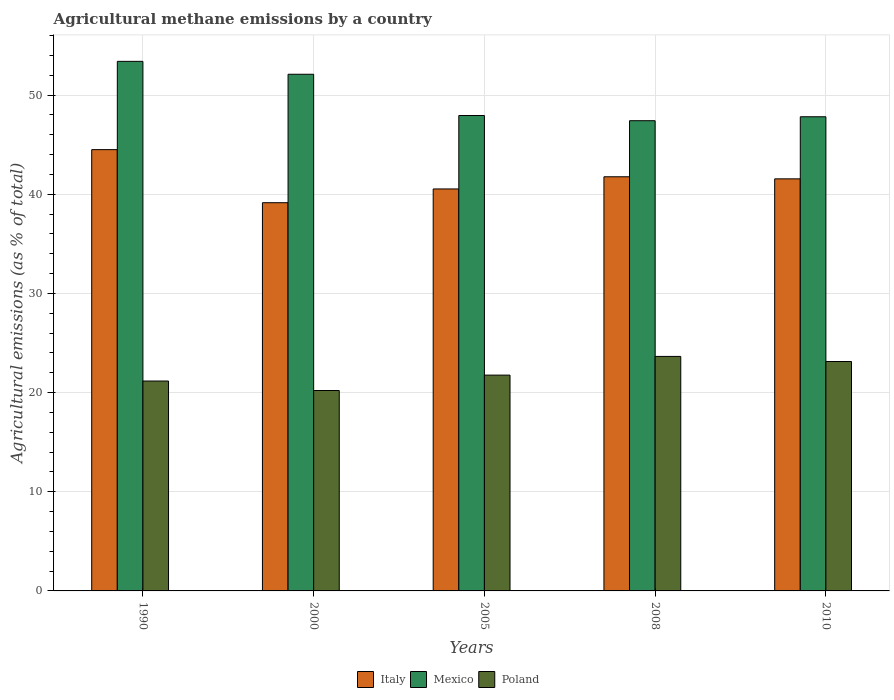How many groups of bars are there?
Your response must be concise. 5. How many bars are there on the 4th tick from the left?
Your answer should be very brief. 3. In how many cases, is the number of bars for a given year not equal to the number of legend labels?
Offer a terse response. 0. What is the amount of agricultural methane emitted in Mexico in 1990?
Provide a short and direct response. 53.39. Across all years, what is the maximum amount of agricultural methane emitted in Poland?
Ensure brevity in your answer.  23.64. Across all years, what is the minimum amount of agricultural methane emitted in Mexico?
Make the answer very short. 47.41. In which year was the amount of agricultural methane emitted in Poland maximum?
Offer a very short reply. 2008. In which year was the amount of agricultural methane emitted in Italy minimum?
Your answer should be compact. 2000. What is the total amount of agricultural methane emitted in Italy in the graph?
Offer a very short reply. 207.46. What is the difference between the amount of agricultural methane emitted in Italy in 2005 and that in 2010?
Keep it short and to the point. -1.02. What is the difference between the amount of agricultural methane emitted in Italy in 2000 and the amount of agricultural methane emitted in Poland in 2008?
Offer a very short reply. 15.5. What is the average amount of agricultural methane emitted in Poland per year?
Keep it short and to the point. 21.98. In the year 2008, what is the difference between the amount of agricultural methane emitted in Mexico and amount of agricultural methane emitted in Poland?
Your answer should be very brief. 23.77. What is the ratio of the amount of agricultural methane emitted in Italy in 2005 to that in 2010?
Your answer should be very brief. 0.98. Is the amount of agricultural methane emitted in Poland in 2005 less than that in 2010?
Provide a succinct answer. Yes. Is the difference between the amount of agricultural methane emitted in Mexico in 2000 and 2008 greater than the difference between the amount of agricultural methane emitted in Poland in 2000 and 2008?
Provide a short and direct response. Yes. What is the difference between the highest and the second highest amount of agricultural methane emitted in Italy?
Give a very brief answer. 2.74. What is the difference between the highest and the lowest amount of agricultural methane emitted in Mexico?
Keep it short and to the point. 5.98. What does the 3rd bar from the left in 2010 represents?
Provide a short and direct response. Poland. What does the 1st bar from the right in 2000 represents?
Offer a very short reply. Poland. Is it the case that in every year, the sum of the amount of agricultural methane emitted in Poland and amount of agricultural methane emitted in Italy is greater than the amount of agricultural methane emitted in Mexico?
Provide a succinct answer. Yes. How many bars are there?
Your answer should be very brief. 15. What is the difference between two consecutive major ticks on the Y-axis?
Your response must be concise. 10. Are the values on the major ticks of Y-axis written in scientific E-notation?
Make the answer very short. No. Where does the legend appear in the graph?
Your answer should be compact. Bottom center. How many legend labels are there?
Ensure brevity in your answer.  3. How are the legend labels stacked?
Offer a terse response. Horizontal. What is the title of the graph?
Provide a short and direct response. Agricultural methane emissions by a country. Does "Least developed countries" appear as one of the legend labels in the graph?
Give a very brief answer. No. What is the label or title of the Y-axis?
Offer a very short reply. Agricultural emissions (as % of total). What is the Agricultural emissions (as % of total) of Italy in 1990?
Provide a short and direct response. 44.49. What is the Agricultural emissions (as % of total) in Mexico in 1990?
Your answer should be compact. 53.39. What is the Agricultural emissions (as % of total) of Poland in 1990?
Provide a short and direct response. 21.16. What is the Agricultural emissions (as % of total) in Italy in 2000?
Your answer should be very brief. 39.14. What is the Agricultural emissions (as % of total) of Mexico in 2000?
Give a very brief answer. 52.09. What is the Agricultural emissions (as % of total) of Poland in 2000?
Your answer should be compact. 20.21. What is the Agricultural emissions (as % of total) in Italy in 2005?
Give a very brief answer. 40.53. What is the Agricultural emissions (as % of total) of Mexico in 2005?
Give a very brief answer. 47.93. What is the Agricultural emissions (as % of total) in Poland in 2005?
Ensure brevity in your answer.  21.76. What is the Agricultural emissions (as % of total) of Italy in 2008?
Provide a short and direct response. 41.76. What is the Agricultural emissions (as % of total) of Mexico in 2008?
Your answer should be compact. 47.41. What is the Agricultural emissions (as % of total) of Poland in 2008?
Make the answer very short. 23.64. What is the Agricultural emissions (as % of total) of Italy in 2010?
Provide a succinct answer. 41.55. What is the Agricultural emissions (as % of total) of Mexico in 2010?
Make the answer very short. 47.81. What is the Agricultural emissions (as % of total) in Poland in 2010?
Ensure brevity in your answer.  23.13. Across all years, what is the maximum Agricultural emissions (as % of total) in Italy?
Give a very brief answer. 44.49. Across all years, what is the maximum Agricultural emissions (as % of total) in Mexico?
Keep it short and to the point. 53.39. Across all years, what is the maximum Agricultural emissions (as % of total) of Poland?
Provide a short and direct response. 23.64. Across all years, what is the minimum Agricultural emissions (as % of total) of Italy?
Your answer should be very brief. 39.14. Across all years, what is the minimum Agricultural emissions (as % of total) in Mexico?
Your answer should be compact. 47.41. Across all years, what is the minimum Agricultural emissions (as % of total) of Poland?
Offer a very short reply. 20.21. What is the total Agricultural emissions (as % of total) of Italy in the graph?
Your response must be concise. 207.46. What is the total Agricultural emissions (as % of total) in Mexico in the graph?
Provide a succinct answer. 248.63. What is the total Agricultural emissions (as % of total) in Poland in the graph?
Ensure brevity in your answer.  109.9. What is the difference between the Agricultural emissions (as % of total) in Italy in 1990 and that in 2000?
Provide a succinct answer. 5.35. What is the difference between the Agricultural emissions (as % of total) in Mexico in 1990 and that in 2000?
Offer a terse response. 1.3. What is the difference between the Agricultural emissions (as % of total) in Poland in 1990 and that in 2000?
Make the answer very short. 0.96. What is the difference between the Agricultural emissions (as % of total) of Italy in 1990 and that in 2005?
Offer a terse response. 3.96. What is the difference between the Agricultural emissions (as % of total) in Mexico in 1990 and that in 2005?
Ensure brevity in your answer.  5.46. What is the difference between the Agricultural emissions (as % of total) in Poland in 1990 and that in 2005?
Provide a short and direct response. -0.6. What is the difference between the Agricultural emissions (as % of total) in Italy in 1990 and that in 2008?
Offer a very short reply. 2.74. What is the difference between the Agricultural emissions (as % of total) of Mexico in 1990 and that in 2008?
Provide a short and direct response. 5.98. What is the difference between the Agricultural emissions (as % of total) of Poland in 1990 and that in 2008?
Your response must be concise. -2.48. What is the difference between the Agricultural emissions (as % of total) of Italy in 1990 and that in 2010?
Your response must be concise. 2.95. What is the difference between the Agricultural emissions (as % of total) in Mexico in 1990 and that in 2010?
Provide a short and direct response. 5.59. What is the difference between the Agricultural emissions (as % of total) in Poland in 1990 and that in 2010?
Offer a very short reply. -1.97. What is the difference between the Agricultural emissions (as % of total) of Italy in 2000 and that in 2005?
Provide a succinct answer. -1.39. What is the difference between the Agricultural emissions (as % of total) of Mexico in 2000 and that in 2005?
Your response must be concise. 4.16. What is the difference between the Agricultural emissions (as % of total) of Poland in 2000 and that in 2005?
Give a very brief answer. -1.55. What is the difference between the Agricultural emissions (as % of total) in Italy in 2000 and that in 2008?
Offer a terse response. -2.62. What is the difference between the Agricultural emissions (as % of total) in Mexico in 2000 and that in 2008?
Give a very brief answer. 4.68. What is the difference between the Agricultural emissions (as % of total) of Poland in 2000 and that in 2008?
Provide a short and direct response. -3.44. What is the difference between the Agricultural emissions (as % of total) of Italy in 2000 and that in 2010?
Offer a terse response. -2.41. What is the difference between the Agricultural emissions (as % of total) of Mexico in 2000 and that in 2010?
Your response must be concise. 4.29. What is the difference between the Agricultural emissions (as % of total) in Poland in 2000 and that in 2010?
Provide a short and direct response. -2.92. What is the difference between the Agricultural emissions (as % of total) of Italy in 2005 and that in 2008?
Offer a terse response. -1.23. What is the difference between the Agricultural emissions (as % of total) of Mexico in 2005 and that in 2008?
Provide a succinct answer. 0.52. What is the difference between the Agricultural emissions (as % of total) in Poland in 2005 and that in 2008?
Your answer should be compact. -1.88. What is the difference between the Agricultural emissions (as % of total) of Italy in 2005 and that in 2010?
Give a very brief answer. -1.02. What is the difference between the Agricultural emissions (as % of total) of Mexico in 2005 and that in 2010?
Provide a short and direct response. 0.13. What is the difference between the Agricultural emissions (as % of total) of Poland in 2005 and that in 2010?
Keep it short and to the point. -1.37. What is the difference between the Agricultural emissions (as % of total) of Italy in 2008 and that in 2010?
Your answer should be compact. 0.21. What is the difference between the Agricultural emissions (as % of total) of Mexico in 2008 and that in 2010?
Offer a very short reply. -0.4. What is the difference between the Agricultural emissions (as % of total) in Poland in 2008 and that in 2010?
Make the answer very short. 0.51. What is the difference between the Agricultural emissions (as % of total) of Italy in 1990 and the Agricultural emissions (as % of total) of Mexico in 2000?
Keep it short and to the point. -7.6. What is the difference between the Agricultural emissions (as % of total) in Italy in 1990 and the Agricultural emissions (as % of total) in Poland in 2000?
Offer a very short reply. 24.29. What is the difference between the Agricultural emissions (as % of total) of Mexico in 1990 and the Agricultural emissions (as % of total) of Poland in 2000?
Your answer should be very brief. 33.19. What is the difference between the Agricultural emissions (as % of total) of Italy in 1990 and the Agricultural emissions (as % of total) of Mexico in 2005?
Ensure brevity in your answer.  -3.44. What is the difference between the Agricultural emissions (as % of total) in Italy in 1990 and the Agricultural emissions (as % of total) in Poland in 2005?
Provide a succinct answer. 22.73. What is the difference between the Agricultural emissions (as % of total) of Mexico in 1990 and the Agricultural emissions (as % of total) of Poland in 2005?
Keep it short and to the point. 31.63. What is the difference between the Agricultural emissions (as % of total) in Italy in 1990 and the Agricultural emissions (as % of total) in Mexico in 2008?
Provide a short and direct response. -2.92. What is the difference between the Agricultural emissions (as % of total) in Italy in 1990 and the Agricultural emissions (as % of total) in Poland in 2008?
Ensure brevity in your answer.  20.85. What is the difference between the Agricultural emissions (as % of total) of Mexico in 1990 and the Agricultural emissions (as % of total) of Poland in 2008?
Your answer should be very brief. 29.75. What is the difference between the Agricultural emissions (as % of total) in Italy in 1990 and the Agricultural emissions (as % of total) in Mexico in 2010?
Ensure brevity in your answer.  -3.31. What is the difference between the Agricultural emissions (as % of total) in Italy in 1990 and the Agricultural emissions (as % of total) in Poland in 2010?
Make the answer very short. 21.36. What is the difference between the Agricultural emissions (as % of total) in Mexico in 1990 and the Agricultural emissions (as % of total) in Poland in 2010?
Make the answer very short. 30.26. What is the difference between the Agricultural emissions (as % of total) of Italy in 2000 and the Agricultural emissions (as % of total) of Mexico in 2005?
Your answer should be very brief. -8.79. What is the difference between the Agricultural emissions (as % of total) in Italy in 2000 and the Agricultural emissions (as % of total) in Poland in 2005?
Make the answer very short. 17.38. What is the difference between the Agricultural emissions (as % of total) in Mexico in 2000 and the Agricultural emissions (as % of total) in Poland in 2005?
Make the answer very short. 30.33. What is the difference between the Agricultural emissions (as % of total) of Italy in 2000 and the Agricultural emissions (as % of total) of Mexico in 2008?
Offer a very short reply. -8.27. What is the difference between the Agricultural emissions (as % of total) in Italy in 2000 and the Agricultural emissions (as % of total) in Poland in 2008?
Provide a succinct answer. 15.5. What is the difference between the Agricultural emissions (as % of total) of Mexico in 2000 and the Agricultural emissions (as % of total) of Poland in 2008?
Your response must be concise. 28.45. What is the difference between the Agricultural emissions (as % of total) of Italy in 2000 and the Agricultural emissions (as % of total) of Mexico in 2010?
Your response must be concise. -8.67. What is the difference between the Agricultural emissions (as % of total) in Italy in 2000 and the Agricultural emissions (as % of total) in Poland in 2010?
Offer a very short reply. 16.01. What is the difference between the Agricultural emissions (as % of total) in Mexico in 2000 and the Agricultural emissions (as % of total) in Poland in 2010?
Ensure brevity in your answer.  28.96. What is the difference between the Agricultural emissions (as % of total) of Italy in 2005 and the Agricultural emissions (as % of total) of Mexico in 2008?
Ensure brevity in your answer.  -6.88. What is the difference between the Agricultural emissions (as % of total) of Italy in 2005 and the Agricultural emissions (as % of total) of Poland in 2008?
Give a very brief answer. 16.89. What is the difference between the Agricultural emissions (as % of total) of Mexico in 2005 and the Agricultural emissions (as % of total) of Poland in 2008?
Keep it short and to the point. 24.29. What is the difference between the Agricultural emissions (as % of total) in Italy in 2005 and the Agricultural emissions (as % of total) in Mexico in 2010?
Make the answer very short. -7.28. What is the difference between the Agricultural emissions (as % of total) of Italy in 2005 and the Agricultural emissions (as % of total) of Poland in 2010?
Your answer should be very brief. 17.4. What is the difference between the Agricultural emissions (as % of total) in Mexico in 2005 and the Agricultural emissions (as % of total) in Poland in 2010?
Your response must be concise. 24.8. What is the difference between the Agricultural emissions (as % of total) of Italy in 2008 and the Agricultural emissions (as % of total) of Mexico in 2010?
Offer a terse response. -6.05. What is the difference between the Agricultural emissions (as % of total) in Italy in 2008 and the Agricultural emissions (as % of total) in Poland in 2010?
Provide a succinct answer. 18.63. What is the difference between the Agricultural emissions (as % of total) in Mexico in 2008 and the Agricultural emissions (as % of total) in Poland in 2010?
Ensure brevity in your answer.  24.28. What is the average Agricultural emissions (as % of total) of Italy per year?
Your answer should be compact. 41.49. What is the average Agricultural emissions (as % of total) of Mexico per year?
Provide a short and direct response. 49.73. What is the average Agricultural emissions (as % of total) of Poland per year?
Your answer should be compact. 21.98. In the year 1990, what is the difference between the Agricultural emissions (as % of total) of Italy and Agricultural emissions (as % of total) of Mexico?
Your answer should be compact. -8.9. In the year 1990, what is the difference between the Agricultural emissions (as % of total) of Italy and Agricultural emissions (as % of total) of Poland?
Your response must be concise. 23.33. In the year 1990, what is the difference between the Agricultural emissions (as % of total) in Mexico and Agricultural emissions (as % of total) in Poland?
Your response must be concise. 32.23. In the year 2000, what is the difference between the Agricultural emissions (as % of total) of Italy and Agricultural emissions (as % of total) of Mexico?
Keep it short and to the point. -12.95. In the year 2000, what is the difference between the Agricultural emissions (as % of total) in Italy and Agricultural emissions (as % of total) in Poland?
Your answer should be very brief. 18.93. In the year 2000, what is the difference between the Agricultural emissions (as % of total) in Mexico and Agricultural emissions (as % of total) in Poland?
Provide a short and direct response. 31.89. In the year 2005, what is the difference between the Agricultural emissions (as % of total) in Italy and Agricultural emissions (as % of total) in Mexico?
Offer a very short reply. -7.4. In the year 2005, what is the difference between the Agricultural emissions (as % of total) of Italy and Agricultural emissions (as % of total) of Poland?
Make the answer very short. 18.77. In the year 2005, what is the difference between the Agricultural emissions (as % of total) in Mexico and Agricultural emissions (as % of total) in Poland?
Make the answer very short. 26.17. In the year 2008, what is the difference between the Agricultural emissions (as % of total) of Italy and Agricultural emissions (as % of total) of Mexico?
Your answer should be very brief. -5.65. In the year 2008, what is the difference between the Agricultural emissions (as % of total) of Italy and Agricultural emissions (as % of total) of Poland?
Offer a very short reply. 18.11. In the year 2008, what is the difference between the Agricultural emissions (as % of total) of Mexico and Agricultural emissions (as % of total) of Poland?
Offer a terse response. 23.77. In the year 2010, what is the difference between the Agricultural emissions (as % of total) in Italy and Agricultural emissions (as % of total) in Mexico?
Provide a short and direct response. -6.26. In the year 2010, what is the difference between the Agricultural emissions (as % of total) in Italy and Agricultural emissions (as % of total) in Poland?
Your response must be concise. 18.42. In the year 2010, what is the difference between the Agricultural emissions (as % of total) in Mexico and Agricultural emissions (as % of total) in Poland?
Provide a succinct answer. 24.68. What is the ratio of the Agricultural emissions (as % of total) of Italy in 1990 to that in 2000?
Your answer should be compact. 1.14. What is the ratio of the Agricultural emissions (as % of total) in Mexico in 1990 to that in 2000?
Provide a short and direct response. 1.02. What is the ratio of the Agricultural emissions (as % of total) of Poland in 1990 to that in 2000?
Offer a very short reply. 1.05. What is the ratio of the Agricultural emissions (as % of total) of Italy in 1990 to that in 2005?
Your response must be concise. 1.1. What is the ratio of the Agricultural emissions (as % of total) in Mexico in 1990 to that in 2005?
Provide a succinct answer. 1.11. What is the ratio of the Agricultural emissions (as % of total) in Poland in 1990 to that in 2005?
Provide a succinct answer. 0.97. What is the ratio of the Agricultural emissions (as % of total) in Italy in 1990 to that in 2008?
Keep it short and to the point. 1.07. What is the ratio of the Agricultural emissions (as % of total) in Mexico in 1990 to that in 2008?
Your answer should be very brief. 1.13. What is the ratio of the Agricultural emissions (as % of total) in Poland in 1990 to that in 2008?
Provide a short and direct response. 0.9. What is the ratio of the Agricultural emissions (as % of total) of Italy in 1990 to that in 2010?
Give a very brief answer. 1.07. What is the ratio of the Agricultural emissions (as % of total) in Mexico in 1990 to that in 2010?
Offer a terse response. 1.12. What is the ratio of the Agricultural emissions (as % of total) of Poland in 1990 to that in 2010?
Offer a terse response. 0.91. What is the ratio of the Agricultural emissions (as % of total) of Italy in 2000 to that in 2005?
Provide a short and direct response. 0.97. What is the ratio of the Agricultural emissions (as % of total) of Mexico in 2000 to that in 2005?
Your answer should be very brief. 1.09. What is the ratio of the Agricultural emissions (as % of total) of Poland in 2000 to that in 2005?
Give a very brief answer. 0.93. What is the ratio of the Agricultural emissions (as % of total) in Italy in 2000 to that in 2008?
Keep it short and to the point. 0.94. What is the ratio of the Agricultural emissions (as % of total) in Mexico in 2000 to that in 2008?
Your answer should be compact. 1.1. What is the ratio of the Agricultural emissions (as % of total) in Poland in 2000 to that in 2008?
Provide a short and direct response. 0.85. What is the ratio of the Agricultural emissions (as % of total) of Italy in 2000 to that in 2010?
Keep it short and to the point. 0.94. What is the ratio of the Agricultural emissions (as % of total) of Mexico in 2000 to that in 2010?
Ensure brevity in your answer.  1.09. What is the ratio of the Agricultural emissions (as % of total) of Poland in 2000 to that in 2010?
Your answer should be compact. 0.87. What is the ratio of the Agricultural emissions (as % of total) of Italy in 2005 to that in 2008?
Ensure brevity in your answer.  0.97. What is the ratio of the Agricultural emissions (as % of total) of Mexico in 2005 to that in 2008?
Offer a very short reply. 1.01. What is the ratio of the Agricultural emissions (as % of total) of Poland in 2005 to that in 2008?
Give a very brief answer. 0.92. What is the ratio of the Agricultural emissions (as % of total) of Italy in 2005 to that in 2010?
Offer a very short reply. 0.98. What is the ratio of the Agricultural emissions (as % of total) in Mexico in 2005 to that in 2010?
Give a very brief answer. 1. What is the ratio of the Agricultural emissions (as % of total) of Poland in 2005 to that in 2010?
Keep it short and to the point. 0.94. What is the ratio of the Agricultural emissions (as % of total) of Italy in 2008 to that in 2010?
Make the answer very short. 1. What is the ratio of the Agricultural emissions (as % of total) in Poland in 2008 to that in 2010?
Keep it short and to the point. 1.02. What is the difference between the highest and the second highest Agricultural emissions (as % of total) of Italy?
Offer a terse response. 2.74. What is the difference between the highest and the second highest Agricultural emissions (as % of total) of Mexico?
Your answer should be compact. 1.3. What is the difference between the highest and the second highest Agricultural emissions (as % of total) in Poland?
Offer a terse response. 0.51. What is the difference between the highest and the lowest Agricultural emissions (as % of total) in Italy?
Make the answer very short. 5.35. What is the difference between the highest and the lowest Agricultural emissions (as % of total) in Mexico?
Provide a succinct answer. 5.98. What is the difference between the highest and the lowest Agricultural emissions (as % of total) in Poland?
Provide a succinct answer. 3.44. 